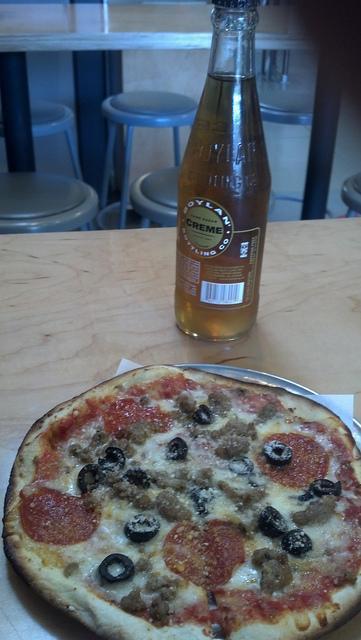How many chairs are visible?
Give a very brief answer. 3. How many coffee cups are in the rack?
Give a very brief answer. 0. 